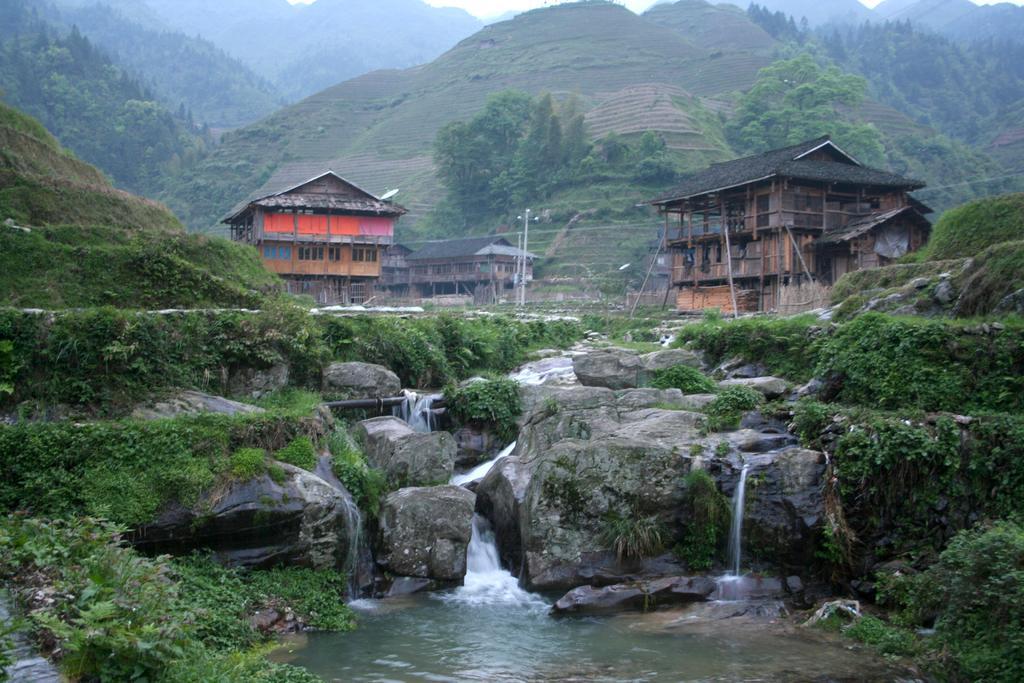In one or two sentences, can you explain what this image depicts? In this image we can see many hills. There are many trees, plants and the few houses in the image. There is a grassy land in the image. In this image we can see a water flow. 